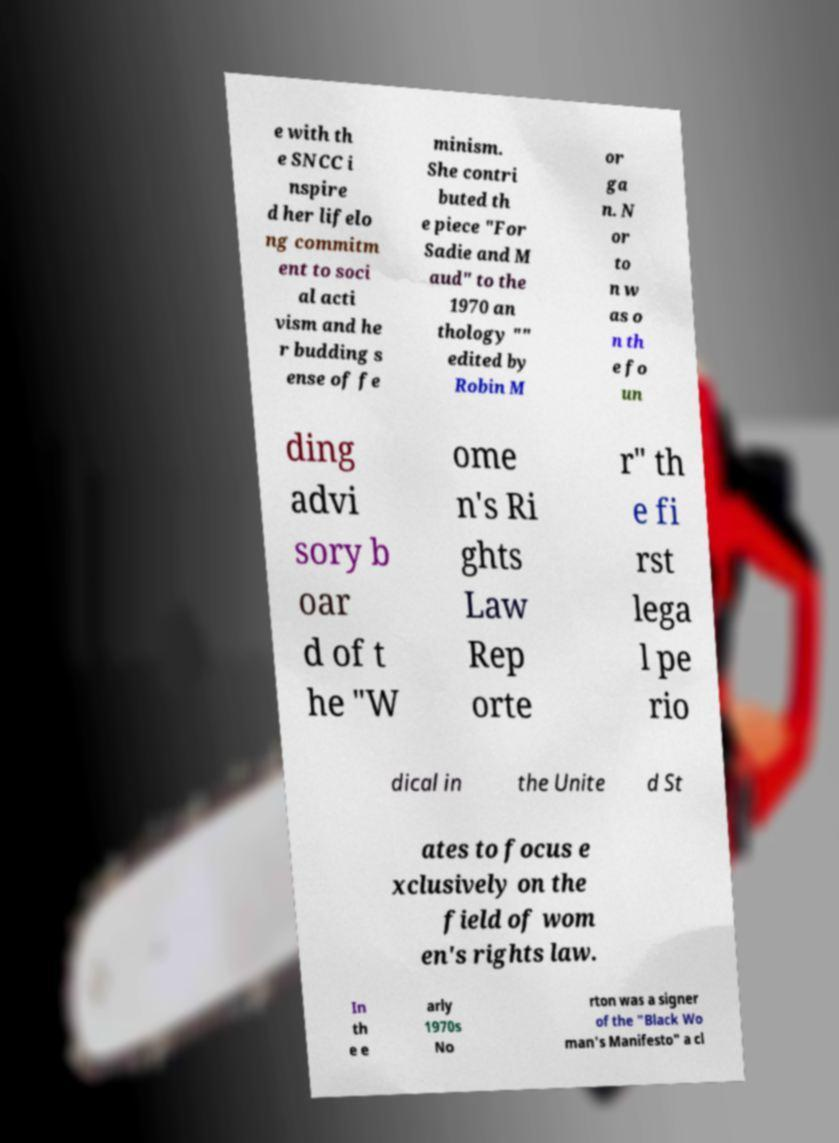Could you extract and type out the text from this image? e with th e SNCC i nspire d her lifelo ng commitm ent to soci al acti vism and he r budding s ense of fe minism. She contri buted th e piece "For Sadie and M aud" to the 1970 an thology "" edited by Robin M or ga n. N or to n w as o n th e fo un ding advi sory b oar d of t he "W ome n's Ri ghts Law Rep orte r" th e fi rst lega l pe rio dical in the Unite d St ates to focus e xclusively on the field of wom en's rights law. In th e e arly 1970s No rton was a signer of the "Black Wo man's Manifesto" a cl 